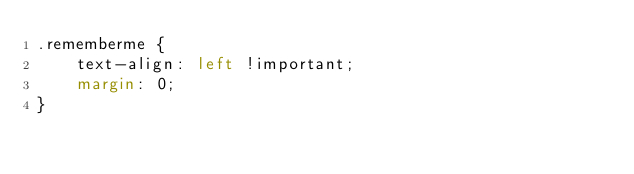Convert code to text. <code><loc_0><loc_0><loc_500><loc_500><_CSS_>.rememberme {
    text-align: left !important;
    margin: 0;
}</code> 